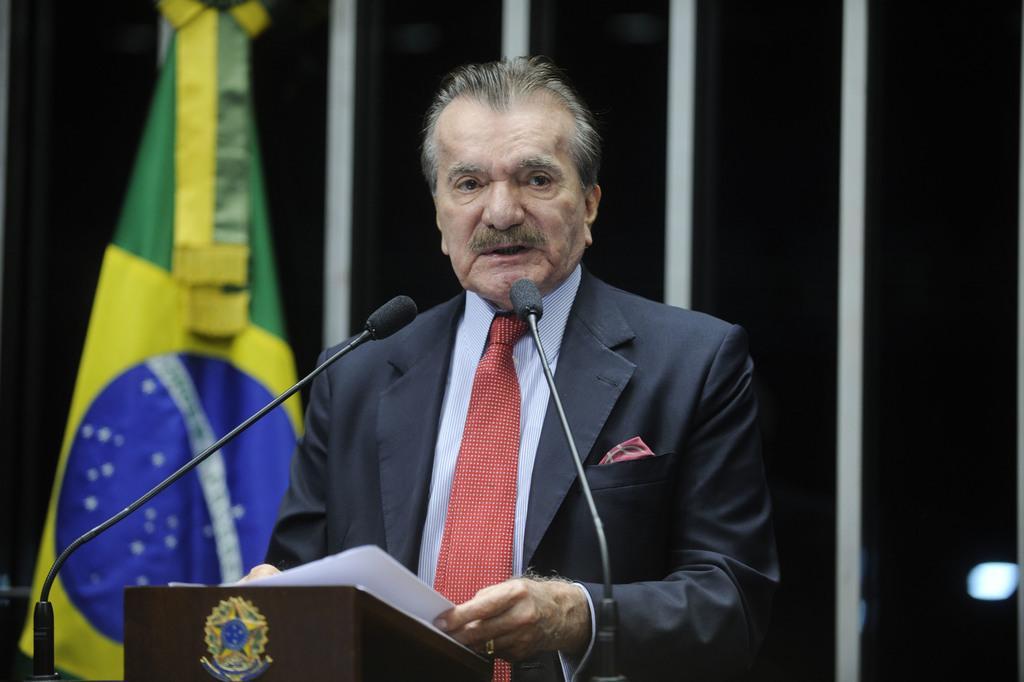Could you give a brief overview of what you see in this image? In this image we can see a person standing and holding a paper, in front of him there is a podium and two mice, also we can see there is a flag and in the background it looks like a wall. 